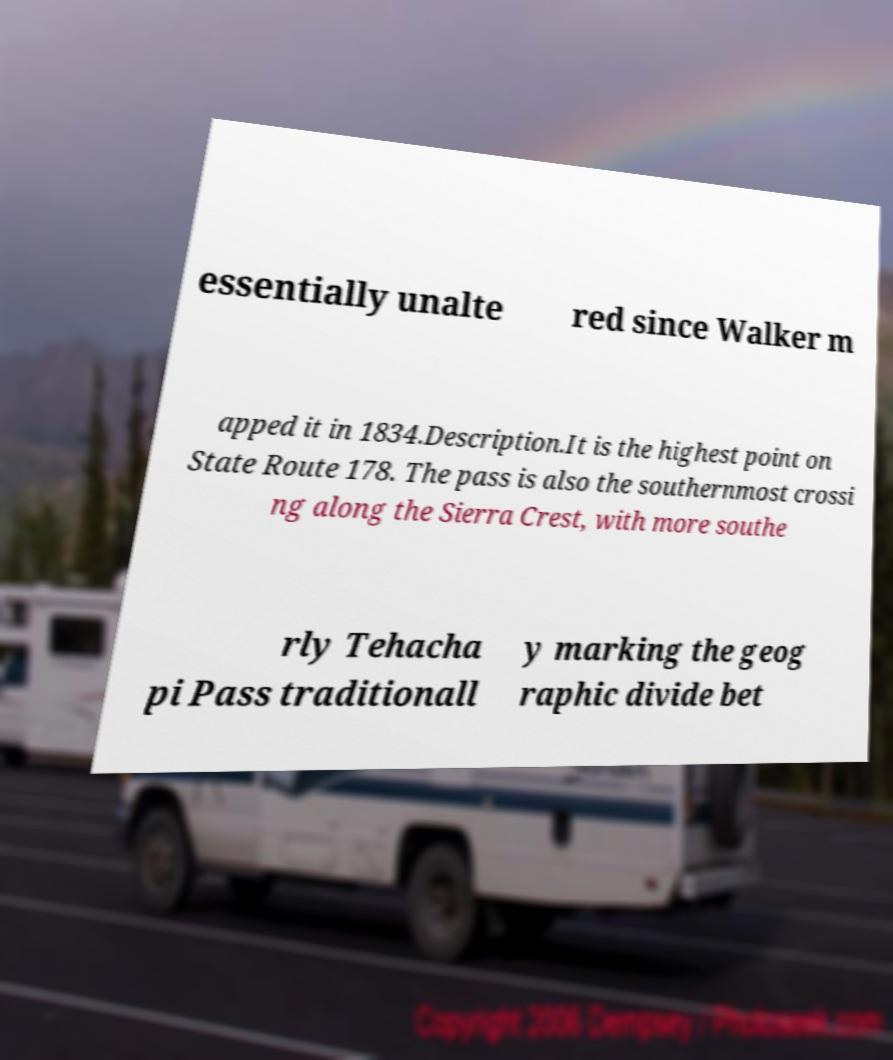Can you read and provide the text displayed in the image?This photo seems to have some interesting text. Can you extract and type it out for me? essentially unalte red since Walker m apped it in 1834.Description.It is the highest point on State Route 178. The pass is also the southernmost crossi ng along the Sierra Crest, with more southe rly Tehacha pi Pass traditionall y marking the geog raphic divide bet 